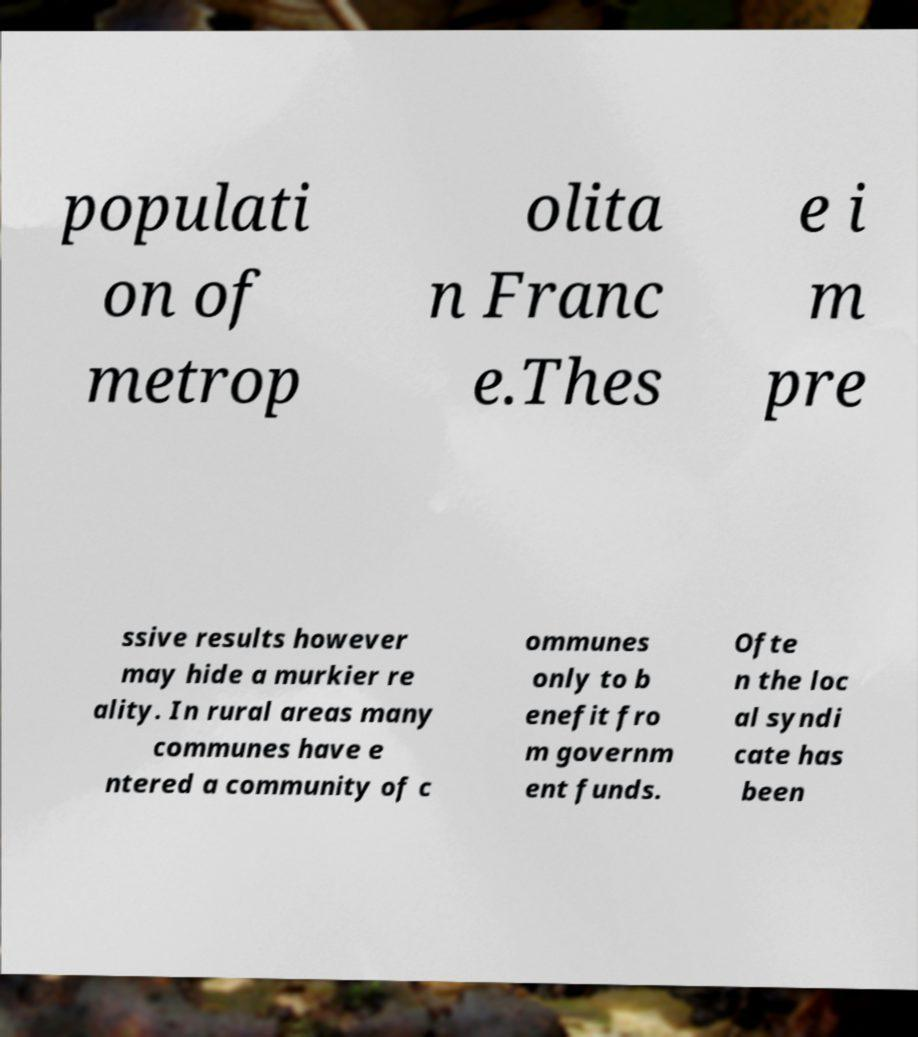I need the written content from this picture converted into text. Can you do that? populati on of metrop olita n Franc e.Thes e i m pre ssive results however may hide a murkier re ality. In rural areas many communes have e ntered a community of c ommunes only to b enefit fro m governm ent funds. Ofte n the loc al syndi cate has been 